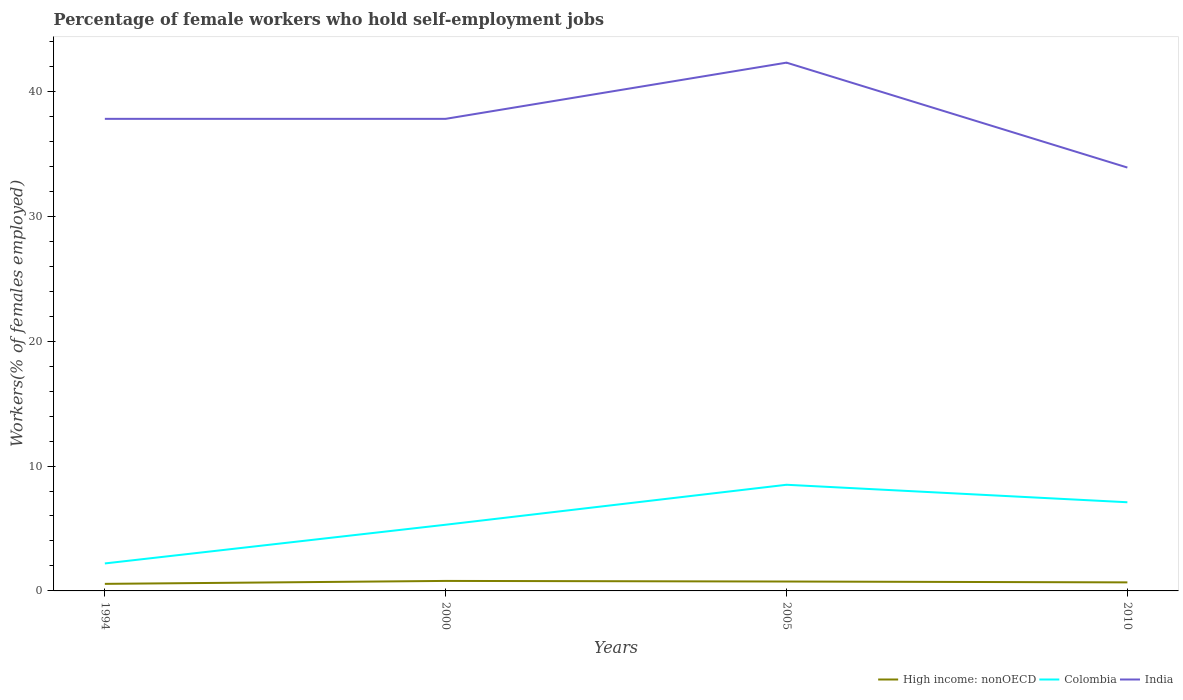How many different coloured lines are there?
Your answer should be compact. 3. Across all years, what is the maximum percentage of self-employed female workers in High income: nonOECD?
Give a very brief answer. 0.57. What is the difference between the highest and the second highest percentage of self-employed female workers in High income: nonOECD?
Your answer should be very brief. 0.24. Is the percentage of self-employed female workers in Colombia strictly greater than the percentage of self-employed female workers in India over the years?
Give a very brief answer. Yes. What is the difference between two consecutive major ticks on the Y-axis?
Give a very brief answer. 10. Does the graph contain any zero values?
Offer a terse response. No. How many legend labels are there?
Keep it short and to the point. 3. How are the legend labels stacked?
Offer a very short reply. Horizontal. What is the title of the graph?
Provide a succinct answer. Percentage of female workers who hold self-employment jobs. Does "Guam" appear as one of the legend labels in the graph?
Ensure brevity in your answer.  No. What is the label or title of the Y-axis?
Offer a terse response. Workers(% of females employed). What is the Workers(% of females employed) in High income: nonOECD in 1994?
Offer a terse response. 0.57. What is the Workers(% of females employed) of Colombia in 1994?
Give a very brief answer. 2.2. What is the Workers(% of females employed) of India in 1994?
Provide a short and direct response. 37.8. What is the Workers(% of females employed) in High income: nonOECD in 2000?
Offer a terse response. 0.8. What is the Workers(% of females employed) in Colombia in 2000?
Your answer should be very brief. 5.3. What is the Workers(% of females employed) in India in 2000?
Your answer should be very brief. 37.8. What is the Workers(% of females employed) of High income: nonOECD in 2005?
Provide a short and direct response. 0.75. What is the Workers(% of females employed) in India in 2005?
Offer a very short reply. 42.3. What is the Workers(% of females employed) of High income: nonOECD in 2010?
Give a very brief answer. 0.68. What is the Workers(% of females employed) of Colombia in 2010?
Your response must be concise. 7.1. What is the Workers(% of females employed) in India in 2010?
Offer a very short reply. 33.9. Across all years, what is the maximum Workers(% of females employed) of High income: nonOECD?
Your response must be concise. 0.8. Across all years, what is the maximum Workers(% of females employed) of Colombia?
Offer a terse response. 8.5. Across all years, what is the maximum Workers(% of females employed) of India?
Provide a short and direct response. 42.3. Across all years, what is the minimum Workers(% of females employed) in High income: nonOECD?
Offer a terse response. 0.57. Across all years, what is the minimum Workers(% of females employed) in Colombia?
Provide a short and direct response. 2.2. Across all years, what is the minimum Workers(% of females employed) of India?
Your answer should be very brief. 33.9. What is the total Workers(% of females employed) in High income: nonOECD in the graph?
Offer a very short reply. 2.8. What is the total Workers(% of females employed) of Colombia in the graph?
Your answer should be very brief. 23.1. What is the total Workers(% of females employed) in India in the graph?
Your answer should be very brief. 151.8. What is the difference between the Workers(% of females employed) of High income: nonOECD in 1994 and that in 2000?
Your response must be concise. -0.24. What is the difference between the Workers(% of females employed) of India in 1994 and that in 2000?
Make the answer very short. 0. What is the difference between the Workers(% of females employed) in High income: nonOECD in 1994 and that in 2005?
Your answer should be compact. -0.19. What is the difference between the Workers(% of females employed) in High income: nonOECD in 1994 and that in 2010?
Keep it short and to the point. -0.12. What is the difference between the Workers(% of females employed) of Colombia in 1994 and that in 2010?
Provide a succinct answer. -4.9. What is the difference between the Workers(% of females employed) of India in 1994 and that in 2010?
Offer a very short reply. 3.9. What is the difference between the Workers(% of females employed) of High income: nonOECD in 2000 and that in 2005?
Offer a very short reply. 0.05. What is the difference between the Workers(% of females employed) of Colombia in 2000 and that in 2005?
Offer a very short reply. -3.2. What is the difference between the Workers(% of females employed) of India in 2000 and that in 2005?
Offer a very short reply. -4.5. What is the difference between the Workers(% of females employed) of High income: nonOECD in 2000 and that in 2010?
Offer a terse response. 0.12. What is the difference between the Workers(% of females employed) of High income: nonOECD in 2005 and that in 2010?
Ensure brevity in your answer.  0.07. What is the difference between the Workers(% of females employed) in Colombia in 2005 and that in 2010?
Ensure brevity in your answer.  1.4. What is the difference between the Workers(% of females employed) in High income: nonOECD in 1994 and the Workers(% of females employed) in Colombia in 2000?
Give a very brief answer. -4.73. What is the difference between the Workers(% of females employed) in High income: nonOECD in 1994 and the Workers(% of females employed) in India in 2000?
Offer a very short reply. -37.23. What is the difference between the Workers(% of females employed) in Colombia in 1994 and the Workers(% of females employed) in India in 2000?
Provide a succinct answer. -35.6. What is the difference between the Workers(% of females employed) in High income: nonOECD in 1994 and the Workers(% of females employed) in Colombia in 2005?
Your answer should be compact. -7.93. What is the difference between the Workers(% of females employed) in High income: nonOECD in 1994 and the Workers(% of females employed) in India in 2005?
Provide a short and direct response. -41.73. What is the difference between the Workers(% of females employed) in Colombia in 1994 and the Workers(% of females employed) in India in 2005?
Your answer should be compact. -40.1. What is the difference between the Workers(% of females employed) of High income: nonOECD in 1994 and the Workers(% of females employed) of Colombia in 2010?
Your answer should be very brief. -6.53. What is the difference between the Workers(% of females employed) of High income: nonOECD in 1994 and the Workers(% of females employed) of India in 2010?
Offer a very short reply. -33.33. What is the difference between the Workers(% of females employed) in Colombia in 1994 and the Workers(% of females employed) in India in 2010?
Offer a very short reply. -31.7. What is the difference between the Workers(% of females employed) in High income: nonOECD in 2000 and the Workers(% of females employed) in Colombia in 2005?
Your response must be concise. -7.7. What is the difference between the Workers(% of females employed) of High income: nonOECD in 2000 and the Workers(% of females employed) of India in 2005?
Offer a terse response. -41.5. What is the difference between the Workers(% of females employed) in Colombia in 2000 and the Workers(% of females employed) in India in 2005?
Give a very brief answer. -37. What is the difference between the Workers(% of females employed) in High income: nonOECD in 2000 and the Workers(% of females employed) in Colombia in 2010?
Offer a terse response. -6.3. What is the difference between the Workers(% of females employed) of High income: nonOECD in 2000 and the Workers(% of females employed) of India in 2010?
Make the answer very short. -33.1. What is the difference between the Workers(% of females employed) of Colombia in 2000 and the Workers(% of females employed) of India in 2010?
Offer a very short reply. -28.6. What is the difference between the Workers(% of females employed) of High income: nonOECD in 2005 and the Workers(% of females employed) of Colombia in 2010?
Ensure brevity in your answer.  -6.35. What is the difference between the Workers(% of females employed) in High income: nonOECD in 2005 and the Workers(% of females employed) in India in 2010?
Your answer should be compact. -33.15. What is the difference between the Workers(% of females employed) in Colombia in 2005 and the Workers(% of females employed) in India in 2010?
Give a very brief answer. -25.4. What is the average Workers(% of females employed) in High income: nonOECD per year?
Offer a very short reply. 0.7. What is the average Workers(% of females employed) in Colombia per year?
Give a very brief answer. 5.78. What is the average Workers(% of females employed) of India per year?
Ensure brevity in your answer.  37.95. In the year 1994, what is the difference between the Workers(% of females employed) of High income: nonOECD and Workers(% of females employed) of Colombia?
Provide a succinct answer. -1.63. In the year 1994, what is the difference between the Workers(% of females employed) of High income: nonOECD and Workers(% of females employed) of India?
Your response must be concise. -37.23. In the year 1994, what is the difference between the Workers(% of females employed) in Colombia and Workers(% of females employed) in India?
Your answer should be compact. -35.6. In the year 2000, what is the difference between the Workers(% of females employed) in High income: nonOECD and Workers(% of females employed) in Colombia?
Offer a terse response. -4.5. In the year 2000, what is the difference between the Workers(% of females employed) of High income: nonOECD and Workers(% of females employed) of India?
Provide a succinct answer. -37. In the year 2000, what is the difference between the Workers(% of females employed) in Colombia and Workers(% of females employed) in India?
Offer a terse response. -32.5. In the year 2005, what is the difference between the Workers(% of females employed) of High income: nonOECD and Workers(% of females employed) of Colombia?
Ensure brevity in your answer.  -7.75. In the year 2005, what is the difference between the Workers(% of females employed) of High income: nonOECD and Workers(% of females employed) of India?
Give a very brief answer. -41.55. In the year 2005, what is the difference between the Workers(% of females employed) of Colombia and Workers(% of females employed) of India?
Your response must be concise. -33.8. In the year 2010, what is the difference between the Workers(% of females employed) in High income: nonOECD and Workers(% of females employed) in Colombia?
Make the answer very short. -6.42. In the year 2010, what is the difference between the Workers(% of females employed) of High income: nonOECD and Workers(% of females employed) of India?
Provide a short and direct response. -33.22. In the year 2010, what is the difference between the Workers(% of females employed) of Colombia and Workers(% of females employed) of India?
Your response must be concise. -26.8. What is the ratio of the Workers(% of females employed) in High income: nonOECD in 1994 to that in 2000?
Provide a short and direct response. 0.71. What is the ratio of the Workers(% of females employed) of Colombia in 1994 to that in 2000?
Your response must be concise. 0.42. What is the ratio of the Workers(% of females employed) in India in 1994 to that in 2000?
Offer a terse response. 1. What is the ratio of the Workers(% of females employed) in High income: nonOECD in 1994 to that in 2005?
Provide a short and direct response. 0.75. What is the ratio of the Workers(% of females employed) of Colombia in 1994 to that in 2005?
Offer a terse response. 0.26. What is the ratio of the Workers(% of females employed) in India in 1994 to that in 2005?
Your answer should be compact. 0.89. What is the ratio of the Workers(% of females employed) in High income: nonOECD in 1994 to that in 2010?
Your answer should be very brief. 0.83. What is the ratio of the Workers(% of females employed) in Colombia in 1994 to that in 2010?
Your response must be concise. 0.31. What is the ratio of the Workers(% of females employed) of India in 1994 to that in 2010?
Give a very brief answer. 1.11. What is the ratio of the Workers(% of females employed) in High income: nonOECD in 2000 to that in 2005?
Offer a very short reply. 1.06. What is the ratio of the Workers(% of females employed) of Colombia in 2000 to that in 2005?
Provide a succinct answer. 0.62. What is the ratio of the Workers(% of females employed) in India in 2000 to that in 2005?
Your answer should be very brief. 0.89. What is the ratio of the Workers(% of females employed) in High income: nonOECD in 2000 to that in 2010?
Give a very brief answer. 1.17. What is the ratio of the Workers(% of females employed) of Colombia in 2000 to that in 2010?
Provide a short and direct response. 0.75. What is the ratio of the Workers(% of females employed) in India in 2000 to that in 2010?
Your response must be concise. 1.11. What is the ratio of the Workers(% of females employed) of High income: nonOECD in 2005 to that in 2010?
Offer a terse response. 1.1. What is the ratio of the Workers(% of females employed) of Colombia in 2005 to that in 2010?
Offer a terse response. 1.2. What is the ratio of the Workers(% of females employed) in India in 2005 to that in 2010?
Provide a succinct answer. 1.25. What is the difference between the highest and the second highest Workers(% of females employed) of High income: nonOECD?
Provide a succinct answer. 0.05. What is the difference between the highest and the second highest Workers(% of females employed) of India?
Give a very brief answer. 4.5. What is the difference between the highest and the lowest Workers(% of females employed) of High income: nonOECD?
Keep it short and to the point. 0.24. What is the difference between the highest and the lowest Workers(% of females employed) of Colombia?
Provide a succinct answer. 6.3. What is the difference between the highest and the lowest Workers(% of females employed) in India?
Provide a short and direct response. 8.4. 